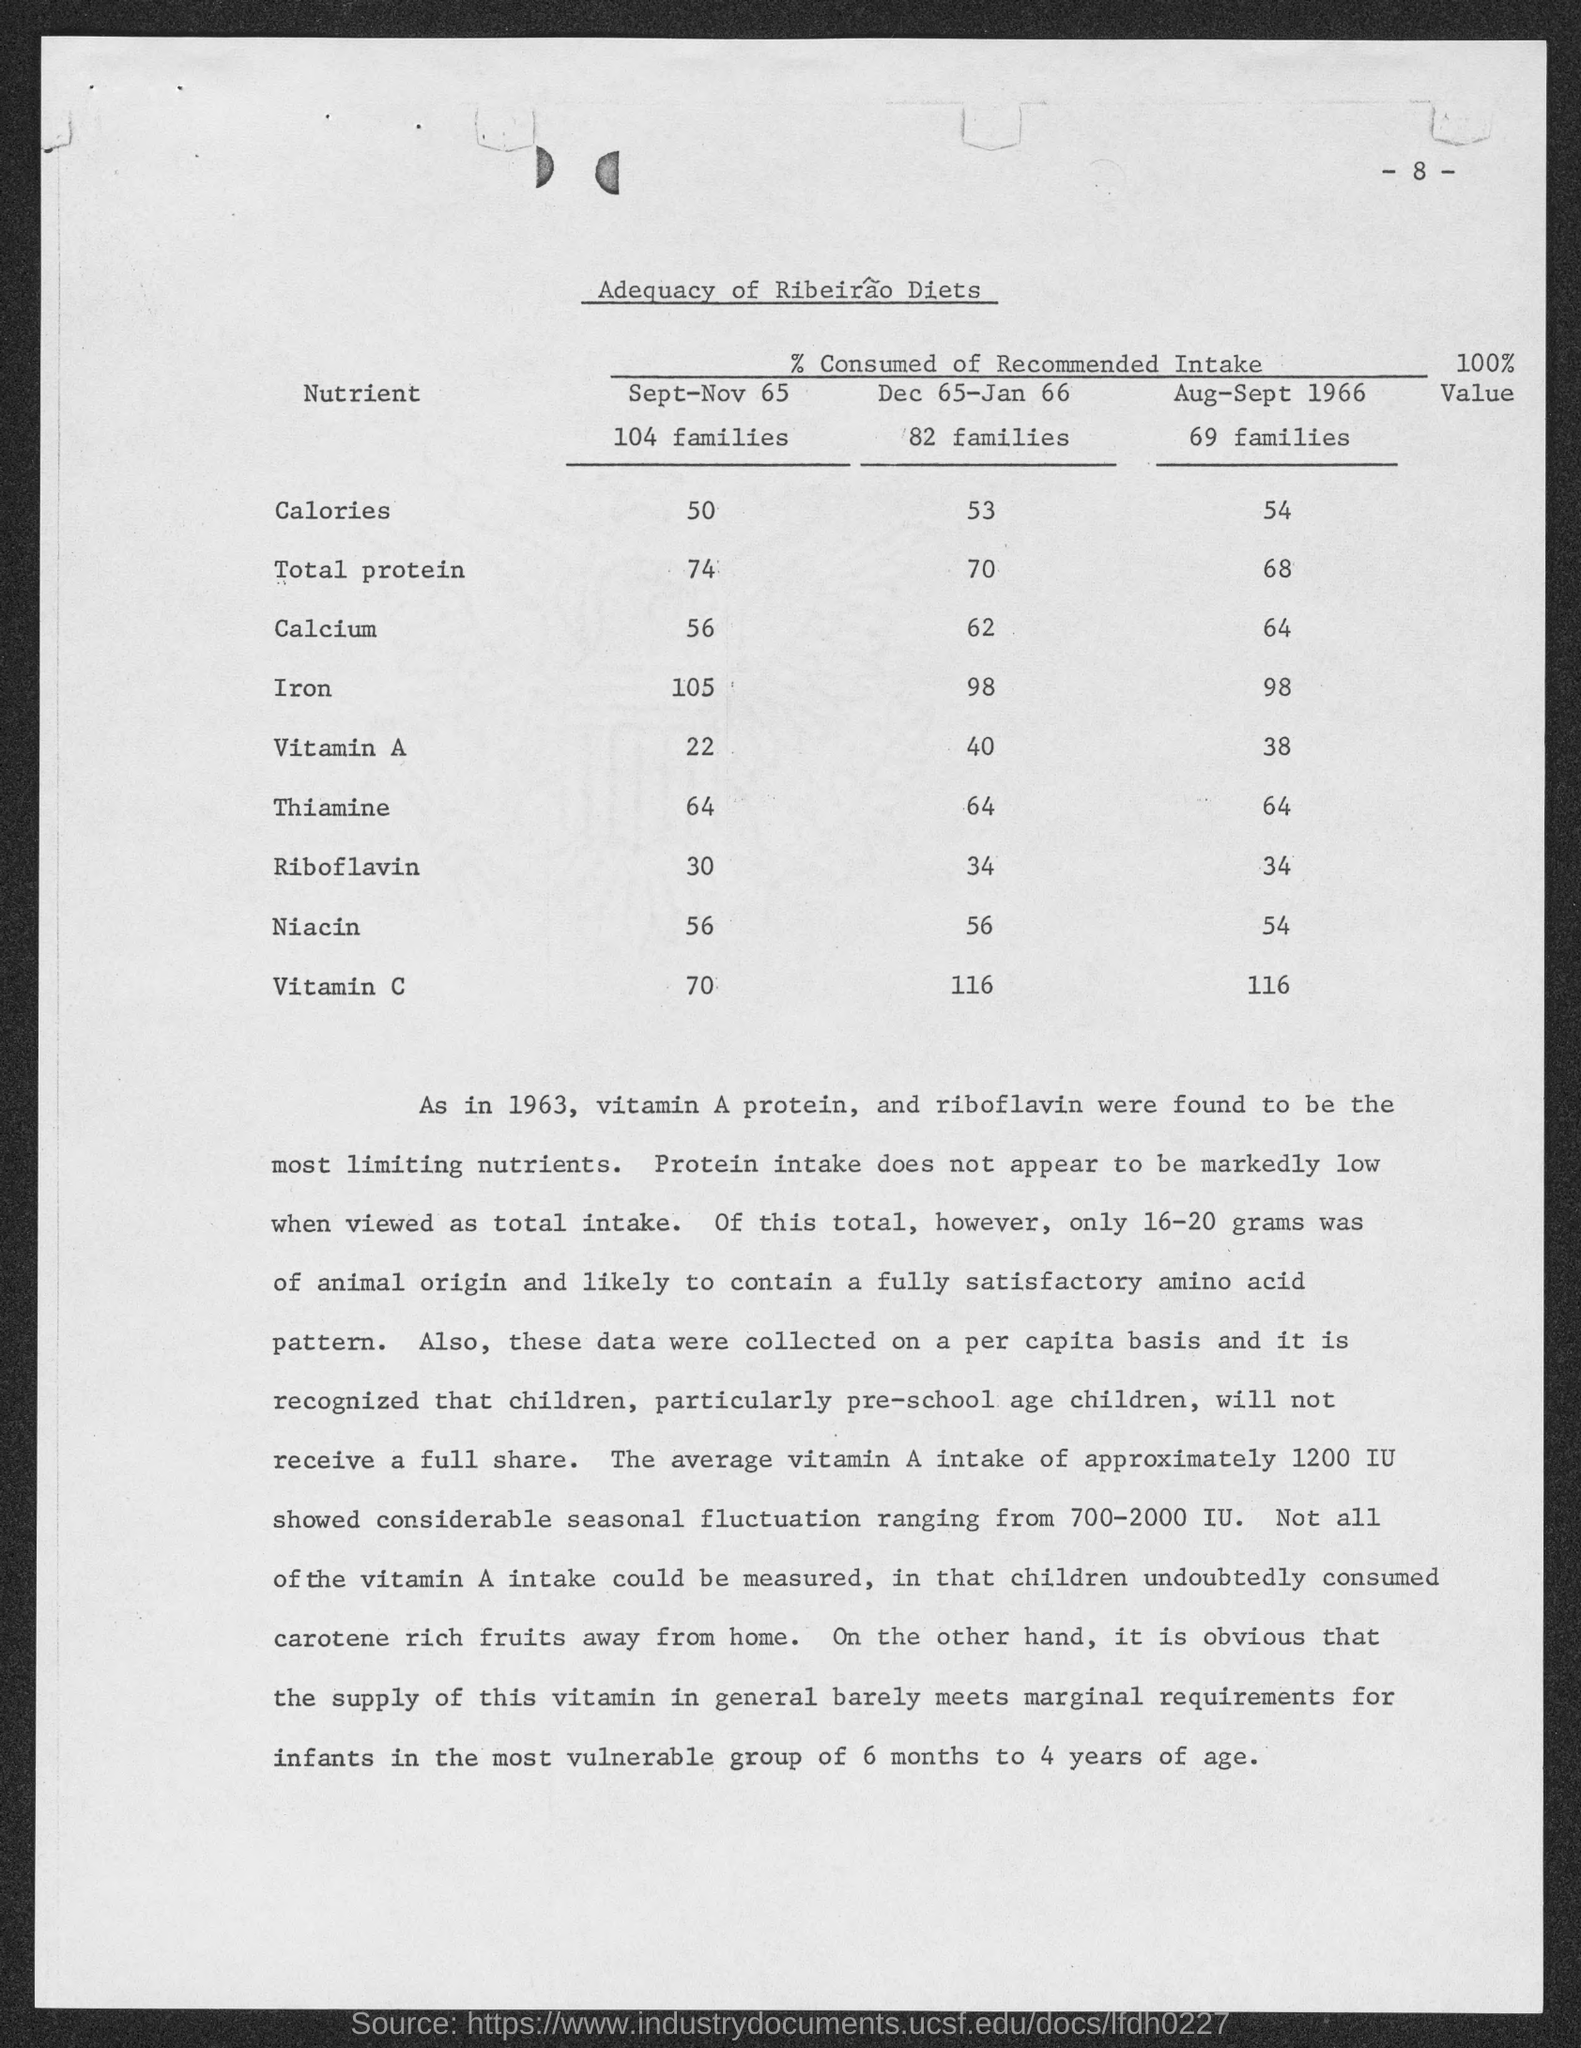What is the  number of this page ?
Your response must be concise. 8. How many number of families are considered from Sept- Nov 65 ?
Your response must be concise. 104 families. How many number of families are considered from Dec 65 - Jan 66 ?
Offer a very short reply. 82. How many number of families are considered from Aug - Sept 1966 ?
Make the answer very short. 69 families. 